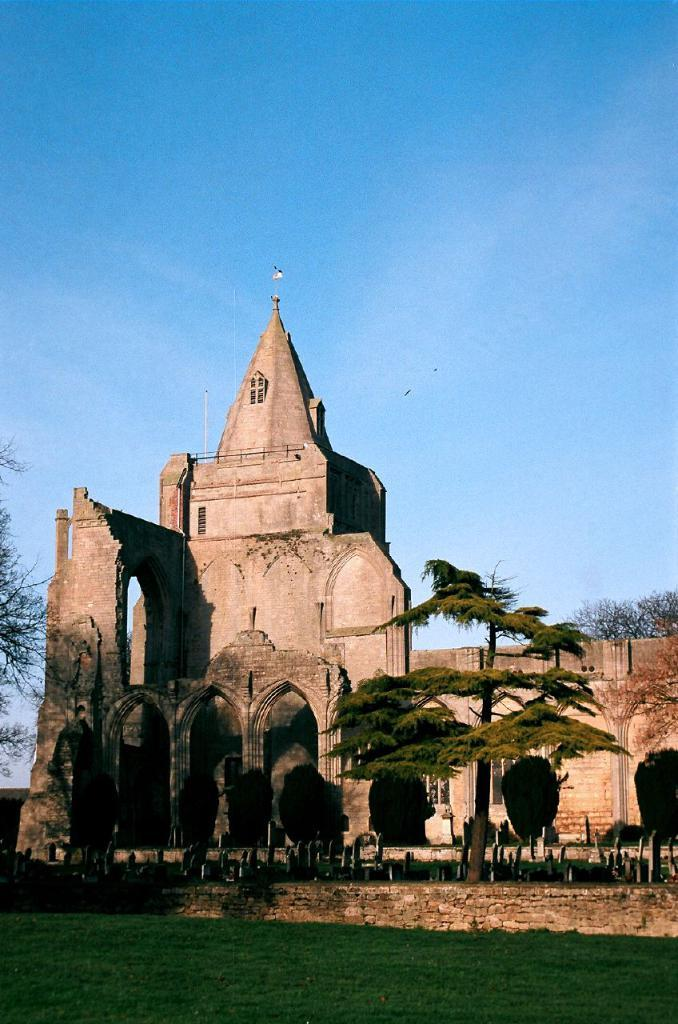What type of vegetation is present in the image? There are trees and grass in the image. What type of structure can be seen in the image? There is a building in the image. What type of food is hidden in the trees in the image? There is no food present in the image, and the trees do not have any hidden items. 